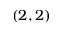Convert formula to latex. <formula><loc_0><loc_0><loc_500><loc_500>( 2 , 2 )</formula> 